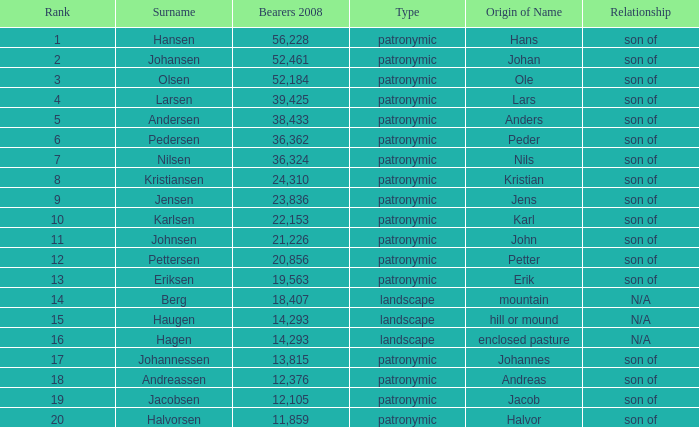What is Type, when Rank is greater than 6, when Number of Bearers 2008 is greater than 13.815, and when Surname is Eriksen? Patronymic. 